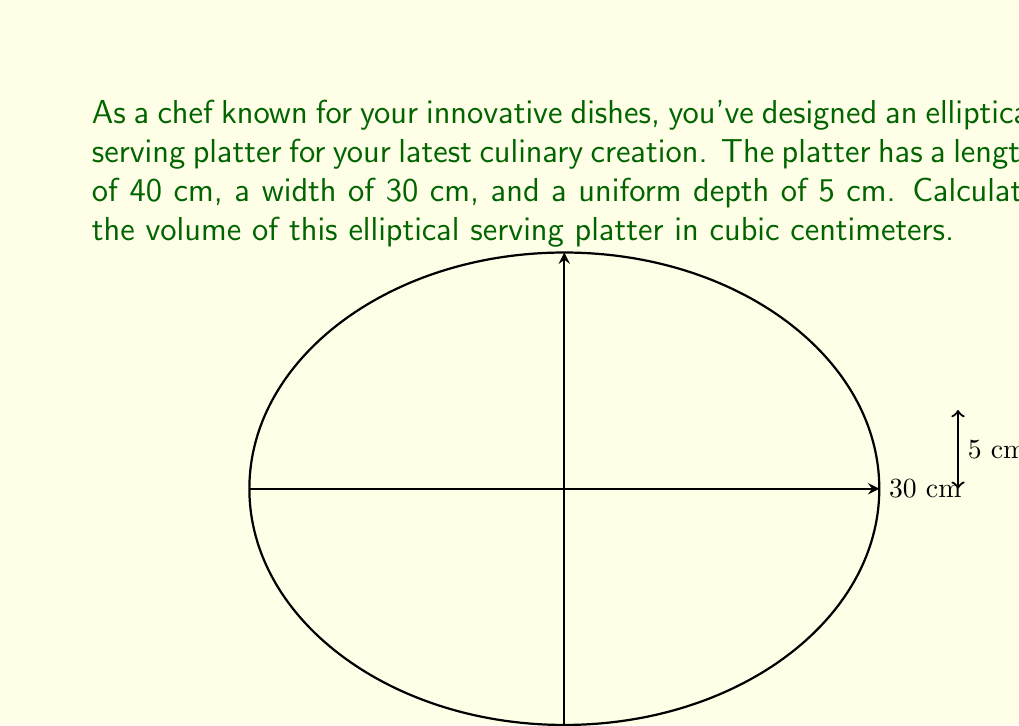What is the answer to this math problem? To calculate the volume of the elliptical serving platter, we need to use the formula for the volume of an elliptical cylinder:

$$V = \pi a b h$$

Where:
$a$ is half the length of the major axis (length)
$b$ is half the length of the minor axis (width)
$h$ is the height (depth) of the platter

Step 1: Determine the values of $a$, $b$, and $h$
$a = 40 \text{ cm} \div 2 = 20 \text{ cm}$
$b = 30 \text{ cm} \div 2 = 15 \text{ cm}$
$h = 5 \text{ cm}$

Step 2: Substitute these values into the volume formula
$$V = \pi (20 \text{ cm})(15 \text{ cm})(5 \text{ cm})$$

Step 3: Calculate the result
$$V = \pi \cdot 1500 \text{ cm}^3 \approx 4712.39 \text{ cm}^3$$

Therefore, the volume of the elliptical serving platter is approximately 4712.39 cubic centimeters.
Answer: $4712.39 \text{ cm}^3$ 